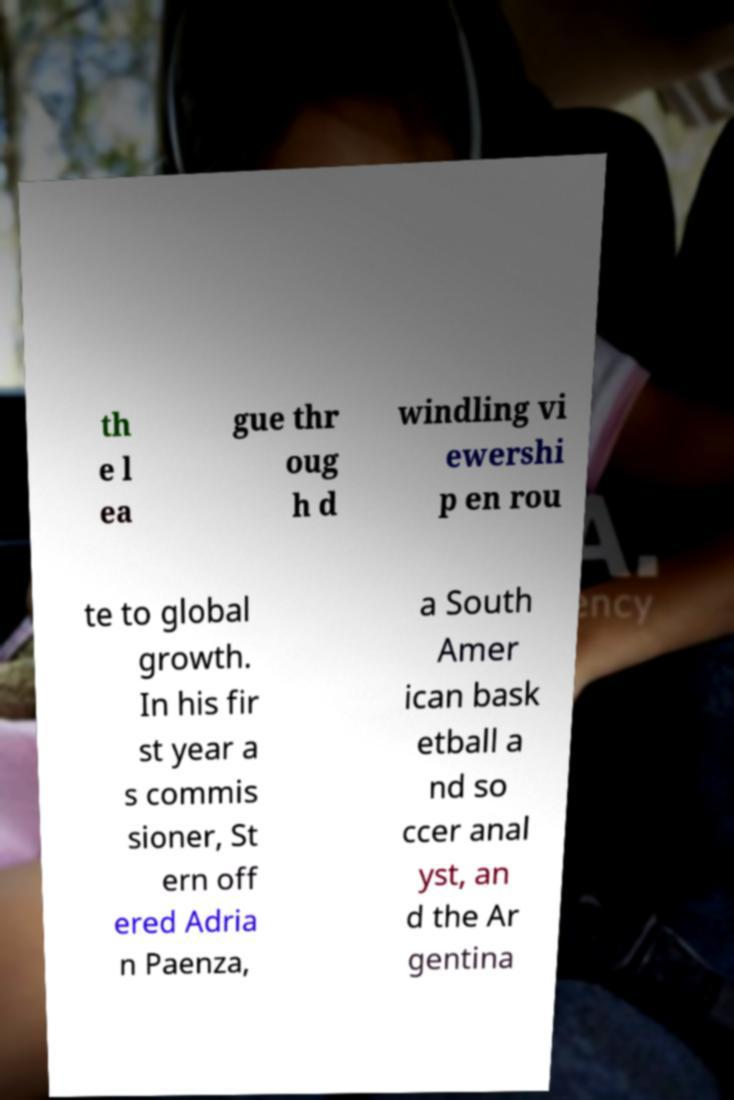Please read and relay the text visible in this image. What does it say? th e l ea gue thr oug h d windling vi ewershi p en rou te to global growth. In his fir st year a s commis sioner, St ern off ered Adria n Paenza, a South Amer ican bask etball a nd so ccer anal yst, an d the Ar gentina 